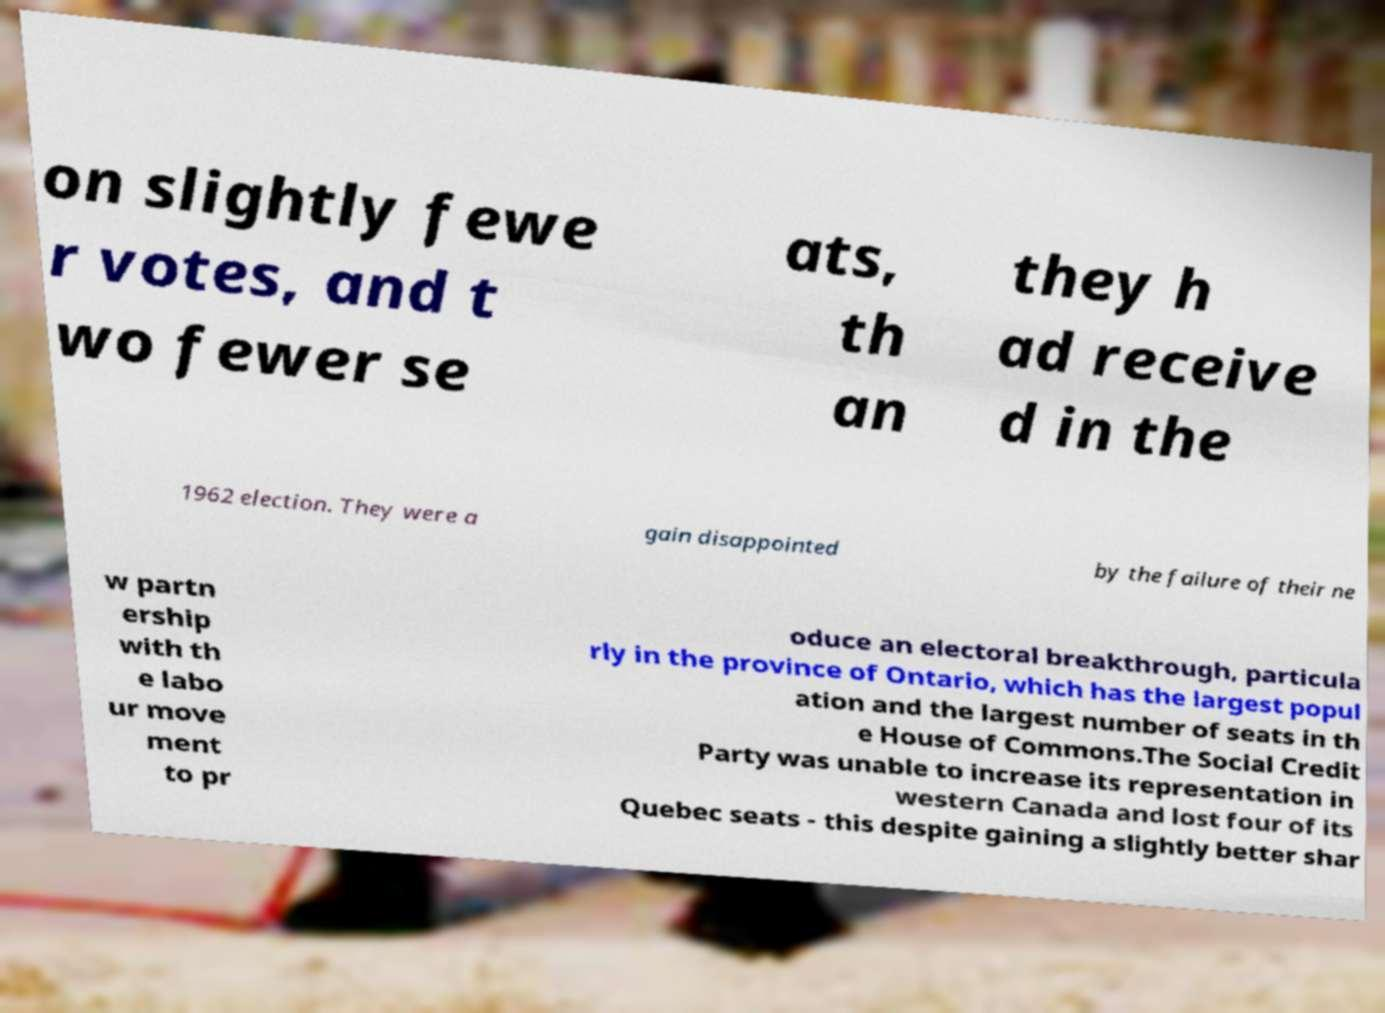I need the written content from this picture converted into text. Can you do that? on slightly fewe r votes, and t wo fewer se ats, th an they h ad receive d in the 1962 election. They were a gain disappointed by the failure of their ne w partn ership with th e labo ur move ment to pr oduce an electoral breakthrough, particula rly in the province of Ontario, which has the largest popul ation and the largest number of seats in th e House of Commons.The Social Credit Party was unable to increase its representation in western Canada and lost four of its Quebec seats - this despite gaining a slightly better shar 